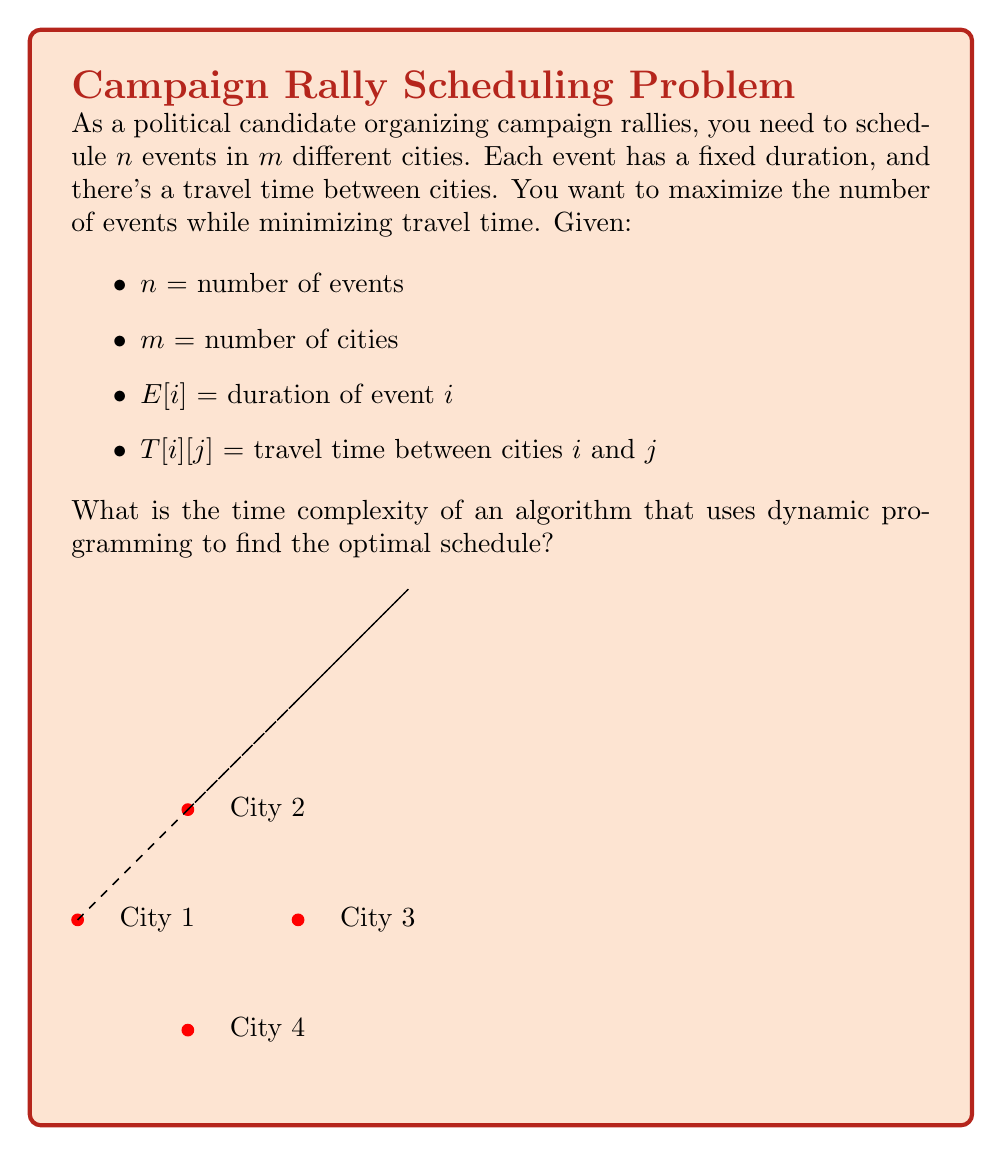Show me your answer to this math problem. To solve this problem optimally using dynamic programming, we need to consider all possible combinations of events and cities. Let's break down the algorithm and analyze its time complexity:

1. We need to create a DP table where:
   - Rows represent the events (1 to $n$)
   - Columns represent the cities (1 to $m$)
   - Each cell $DP[i][j]$ stores the maximum number of events that can be scheduled up to event $i$, ending in city $j$

2. The recurrence relation for filling the DP table would be:
   $$DP[i][j] = \max_{k=1}^m \{DP[i-1][k] + f(k,j,i)\}$$
   where $f(k,j,i)$ is 1 if we can schedule event $i$ in city $j$ after the previous event in city $k$, and 0 otherwise.

3. To fill each cell in the DP table:
   - We need to check all $m$ cities for the previous event (outer loop)
   - For each previous city, we need to check if we can schedule the current event (constant time operation)

4. The dimensions of the DP table are $n \times m$

5. Therefore, the time complexity to fill the entire DP table is:
   $$O(n \times m \times m) = O(nm^2)$$

6. After filling the DP table, we need to find the maximum value in the last row to get the optimal number of events, which takes $O(m)$ time.

7. To reconstruct the optimal schedule, we need to backtrack through the DP table, which takes $O(n)$ time in the worst case.

The dominating factor in the time complexity is filling the DP table, so the overall time complexity of the algorithm is $O(nm^2)$.
Answer: $O(nm^2)$ 